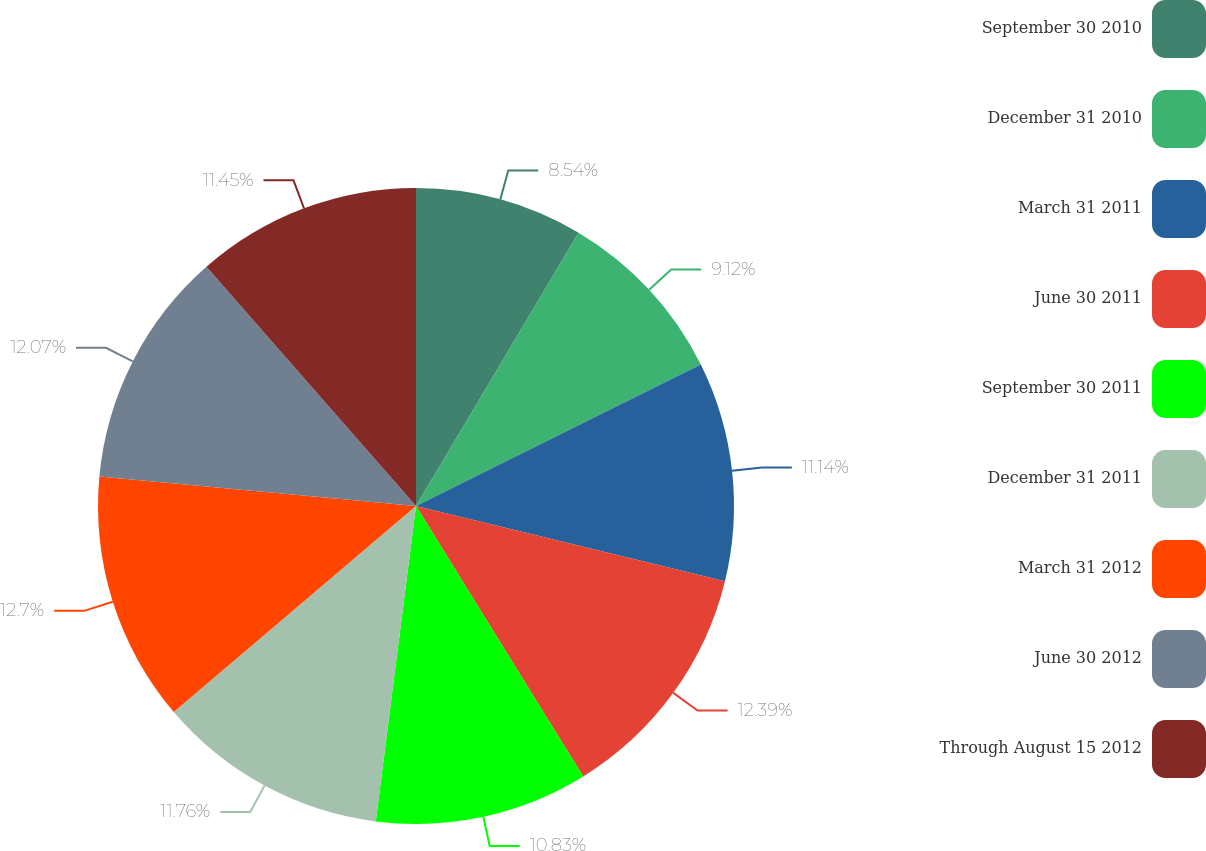Convert chart to OTSL. <chart><loc_0><loc_0><loc_500><loc_500><pie_chart><fcel>September 30 2010<fcel>December 31 2010<fcel>March 31 2011<fcel>June 30 2011<fcel>September 30 2011<fcel>December 31 2011<fcel>March 31 2012<fcel>June 30 2012<fcel>Through August 15 2012<nl><fcel>8.54%<fcel>9.12%<fcel>11.14%<fcel>12.38%<fcel>10.83%<fcel>11.76%<fcel>12.69%<fcel>12.07%<fcel>11.45%<nl></chart> 